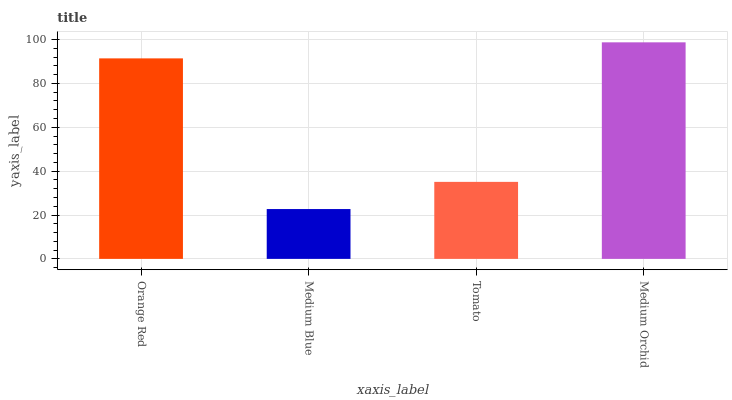Is Medium Blue the minimum?
Answer yes or no. Yes. Is Medium Orchid the maximum?
Answer yes or no. Yes. Is Tomato the minimum?
Answer yes or no. No. Is Tomato the maximum?
Answer yes or no. No. Is Tomato greater than Medium Blue?
Answer yes or no. Yes. Is Medium Blue less than Tomato?
Answer yes or no. Yes. Is Medium Blue greater than Tomato?
Answer yes or no. No. Is Tomato less than Medium Blue?
Answer yes or no. No. Is Orange Red the high median?
Answer yes or no. Yes. Is Tomato the low median?
Answer yes or no. Yes. Is Medium Blue the high median?
Answer yes or no. No. Is Orange Red the low median?
Answer yes or no. No. 